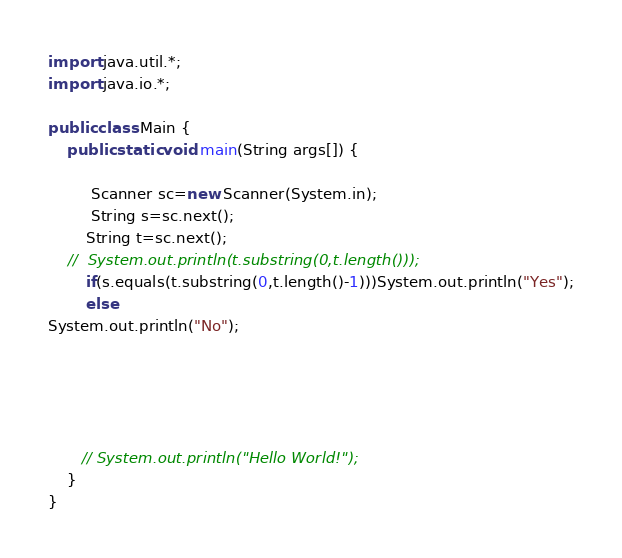<code> <loc_0><loc_0><loc_500><loc_500><_Java_>import java.util.*;
import java.io.*;

public class Main {
    public static void main(String args[]) {

         Scanner sc=new Scanner(System.in);
		 String s=sc.next();
		String t=sc.next();
	//	System.out.println(t.substring(0,t.length()));
		if(s.equals(t.substring(0,t.length()-1)))System.out.println("Yes");
		else
System.out.println("No");




         
       // System.out.println("Hello World!");
    }
}</code> 